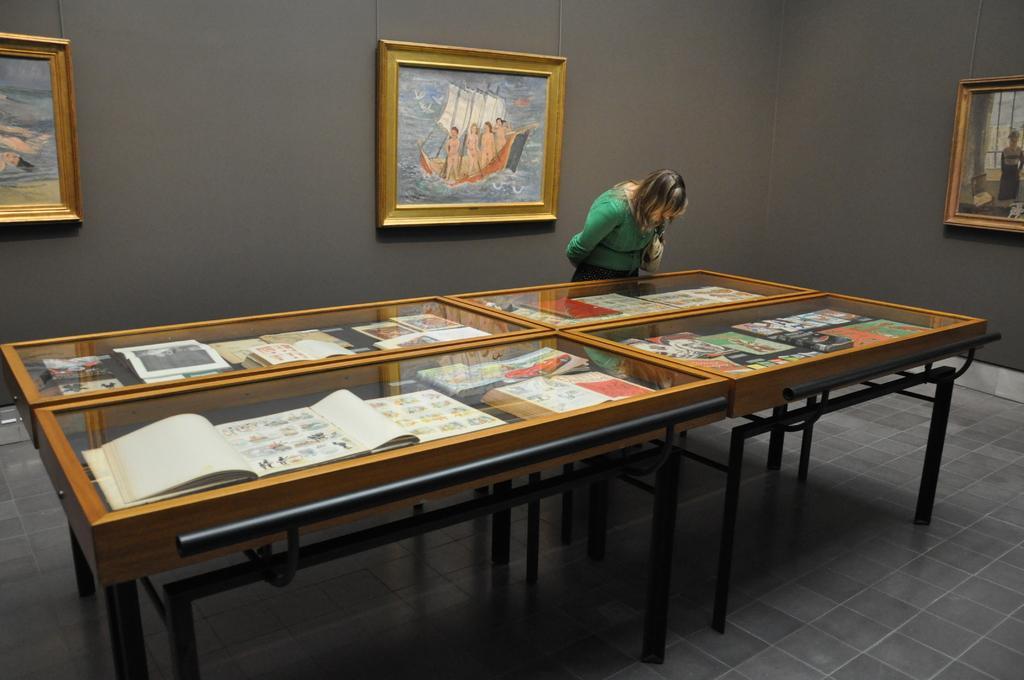How would you summarize this image in a sentence or two? In this image the woman is standing in front of the table. The frames are attached to the wall. 